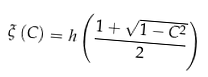Convert formula to latex. <formula><loc_0><loc_0><loc_500><loc_500>\xi \left ( C \right ) = h \left ( \frac { 1 + \sqrt { 1 - C ^ { 2 } } } { 2 } \right )</formula> 